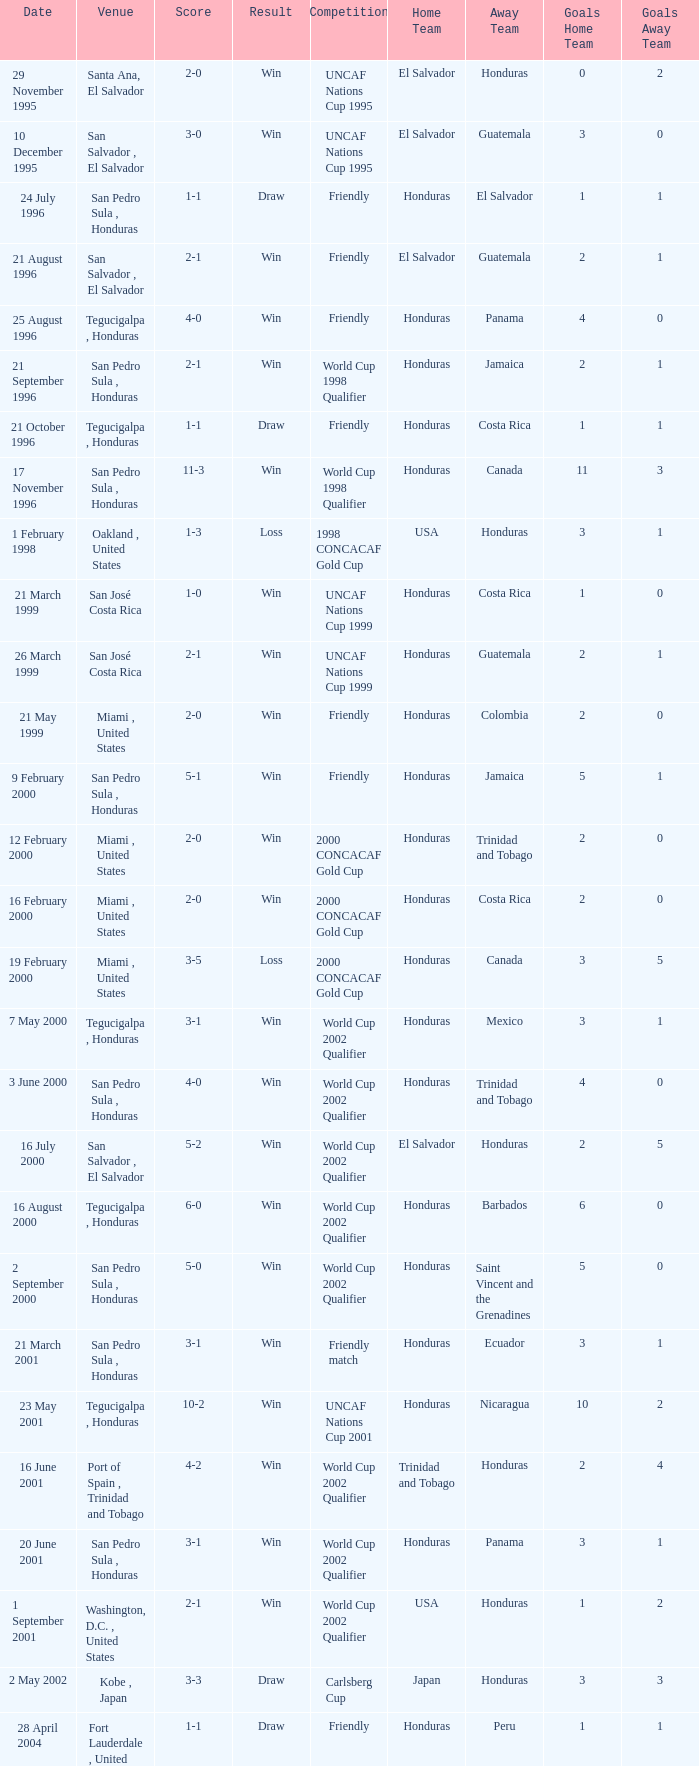What is the venue for the friendly competition and score of 4-0? Tegucigalpa , Honduras. 